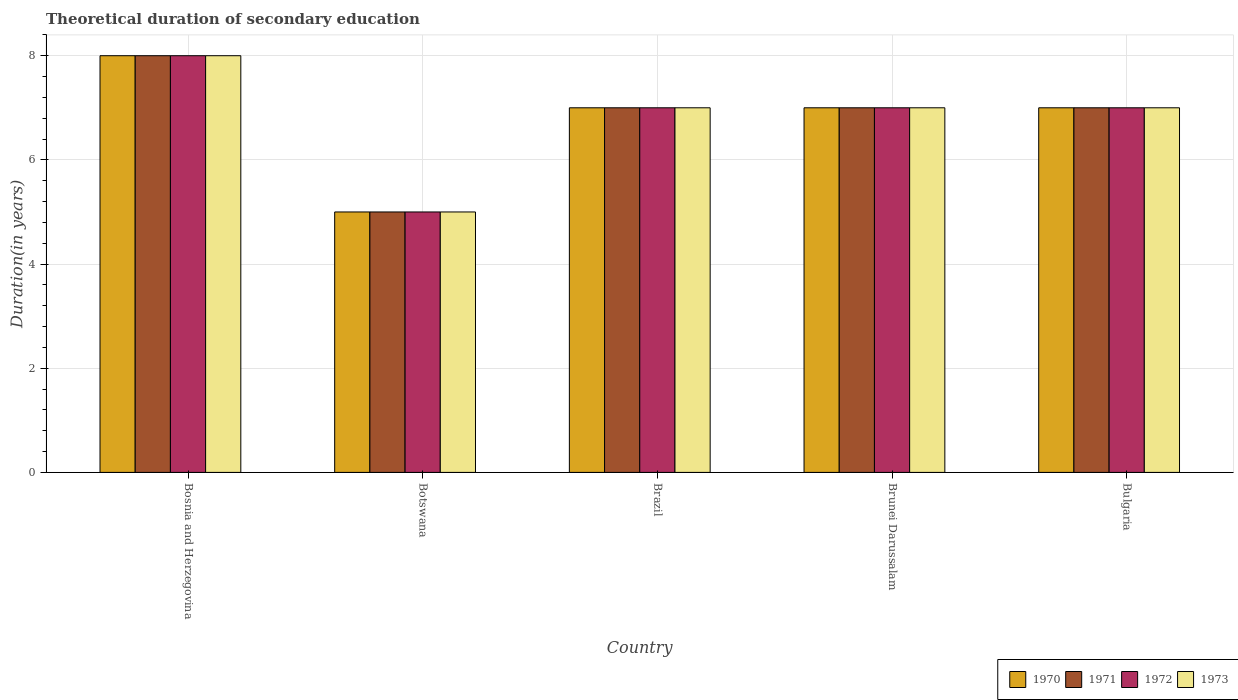How many groups of bars are there?
Provide a succinct answer. 5. Are the number of bars on each tick of the X-axis equal?
Keep it short and to the point. Yes. How many bars are there on the 5th tick from the left?
Your response must be concise. 4. How many bars are there on the 2nd tick from the right?
Offer a very short reply. 4. What is the label of the 2nd group of bars from the left?
Provide a succinct answer. Botswana. In how many cases, is the number of bars for a given country not equal to the number of legend labels?
Make the answer very short. 0. What is the total theoretical duration of secondary education in 1971 in Bulgaria?
Keep it short and to the point. 7. In which country was the total theoretical duration of secondary education in 1972 maximum?
Offer a very short reply. Bosnia and Herzegovina. In which country was the total theoretical duration of secondary education in 1971 minimum?
Make the answer very short. Botswana. What is the total total theoretical duration of secondary education in 1973 in the graph?
Your response must be concise. 34. What is the difference between the total theoretical duration of secondary education in 1972 in Brazil and that in Brunei Darussalam?
Provide a succinct answer. 0. What is the average total theoretical duration of secondary education in 1970 per country?
Your response must be concise. 6.8. In how many countries, is the total theoretical duration of secondary education in 1972 greater than 3.6 years?
Offer a terse response. 5. What is the ratio of the total theoretical duration of secondary education in 1971 in Bosnia and Herzegovina to that in Brunei Darussalam?
Offer a very short reply. 1.14. What is the difference between the highest and the lowest total theoretical duration of secondary education in 1972?
Ensure brevity in your answer.  3. In how many countries, is the total theoretical duration of secondary education in 1970 greater than the average total theoretical duration of secondary education in 1970 taken over all countries?
Your response must be concise. 4. Is it the case that in every country, the sum of the total theoretical duration of secondary education in 1971 and total theoretical duration of secondary education in 1972 is greater than the sum of total theoretical duration of secondary education in 1970 and total theoretical duration of secondary education in 1973?
Give a very brief answer. No. Is it the case that in every country, the sum of the total theoretical duration of secondary education in 1970 and total theoretical duration of secondary education in 1972 is greater than the total theoretical duration of secondary education in 1971?
Make the answer very short. Yes. How many bars are there?
Give a very brief answer. 20. Are all the bars in the graph horizontal?
Provide a succinct answer. No. What is the difference between two consecutive major ticks on the Y-axis?
Ensure brevity in your answer.  2. Are the values on the major ticks of Y-axis written in scientific E-notation?
Provide a short and direct response. No. Does the graph contain any zero values?
Your answer should be very brief. No. What is the title of the graph?
Your answer should be very brief. Theoretical duration of secondary education. Does "2015" appear as one of the legend labels in the graph?
Offer a very short reply. No. What is the label or title of the Y-axis?
Your answer should be compact. Duration(in years). What is the Duration(in years) of 1972 in Bosnia and Herzegovina?
Offer a very short reply. 8. What is the Duration(in years) of 1973 in Bosnia and Herzegovina?
Offer a terse response. 8. What is the Duration(in years) of 1971 in Botswana?
Your answer should be compact. 5. What is the Duration(in years) of 1973 in Botswana?
Make the answer very short. 5. What is the Duration(in years) of 1970 in Brazil?
Keep it short and to the point. 7. What is the Duration(in years) in 1970 in Bulgaria?
Make the answer very short. 7. What is the Duration(in years) in 1971 in Bulgaria?
Keep it short and to the point. 7. Across all countries, what is the maximum Duration(in years) of 1970?
Provide a succinct answer. 8. Across all countries, what is the maximum Duration(in years) of 1971?
Ensure brevity in your answer.  8. Across all countries, what is the maximum Duration(in years) of 1972?
Your answer should be very brief. 8. Across all countries, what is the maximum Duration(in years) of 1973?
Your answer should be very brief. 8. Across all countries, what is the minimum Duration(in years) in 1970?
Make the answer very short. 5. Across all countries, what is the minimum Duration(in years) in 1973?
Give a very brief answer. 5. What is the total Duration(in years) in 1970 in the graph?
Your answer should be compact. 34. What is the total Duration(in years) in 1973 in the graph?
Provide a short and direct response. 34. What is the difference between the Duration(in years) of 1970 in Bosnia and Herzegovina and that in Botswana?
Keep it short and to the point. 3. What is the difference between the Duration(in years) in 1971 in Bosnia and Herzegovina and that in Botswana?
Your answer should be very brief. 3. What is the difference between the Duration(in years) in 1972 in Bosnia and Herzegovina and that in Botswana?
Provide a succinct answer. 3. What is the difference between the Duration(in years) of 1973 in Bosnia and Herzegovina and that in Botswana?
Your answer should be compact. 3. What is the difference between the Duration(in years) of 1971 in Bosnia and Herzegovina and that in Brazil?
Ensure brevity in your answer.  1. What is the difference between the Duration(in years) in 1972 in Bosnia and Herzegovina and that in Brazil?
Make the answer very short. 1. What is the difference between the Duration(in years) of 1970 in Bosnia and Herzegovina and that in Brunei Darussalam?
Your response must be concise. 1. What is the difference between the Duration(in years) of 1970 in Bosnia and Herzegovina and that in Bulgaria?
Offer a terse response. 1. What is the difference between the Duration(in years) in 1973 in Bosnia and Herzegovina and that in Bulgaria?
Your response must be concise. 1. What is the difference between the Duration(in years) of 1971 in Botswana and that in Brazil?
Give a very brief answer. -2. What is the difference between the Duration(in years) of 1973 in Botswana and that in Brazil?
Provide a short and direct response. -2. What is the difference between the Duration(in years) in 1971 in Botswana and that in Brunei Darussalam?
Offer a terse response. -2. What is the difference between the Duration(in years) in 1972 in Botswana and that in Brunei Darussalam?
Provide a short and direct response. -2. What is the difference between the Duration(in years) of 1973 in Botswana and that in Brunei Darussalam?
Offer a very short reply. -2. What is the difference between the Duration(in years) in 1970 in Botswana and that in Bulgaria?
Offer a terse response. -2. What is the difference between the Duration(in years) of 1971 in Brazil and that in Brunei Darussalam?
Offer a very short reply. 0. What is the difference between the Duration(in years) of 1972 in Brazil and that in Brunei Darussalam?
Your answer should be very brief. 0. What is the difference between the Duration(in years) in 1970 in Brazil and that in Bulgaria?
Your answer should be compact. 0. What is the difference between the Duration(in years) in 1971 in Brazil and that in Bulgaria?
Your answer should be very brief. 0. What is the difference between the Duration(in years) of 1973 in Brazil and that in Bulgaria?
Your answer should be very brief. 0. What is the difference between the Duration(in years) of 1973 in Brunei Darussalam and that in Bulgaria?
Make the answer very short. 0. What is the difference between the Duration(in years) in 1970 in Bosnia and Herzegovina and the Duration(in years) in 1972 in Botswana?
Offer a terse response. 3. What is the difference between the Duration(in years) of 1971 in Bosnia and Herzegovina and the Duration(in years) of 1972 in Botswana?
Provide a succinct answer. 3. What is the difference between the Duration(in years) in 1970 in Bosnia and Herzegovina and the Duration(in years) in 1972 in Brazil?
Offer a very short reply. 1. What is the difference between the Duration(in years) of 1970 in Bosnia and Herzegovina and the Duration(in years) of 1973 in Brazil?
Offer a terse response. 1. What is the difference between the Duration(in years) of 1971 in Bosnia and Herzegovina and the Duration(in years) of 1972 in Brazil?
Provide a short and direct response. 1. What is the difference between the Duration(in years) in 1972 in Bosnia and Herzegovina and the Duration(in years) in 1973 in Brazil?
Give a very brief answer. 1. What is the difference between the Duration(in years) of 1970 in Bosnia and Herzegovina and the Duration(in years) of 1973 in Brunei Darussalam?
Provide a short and direct response. 1. What is the difference between the Duration(in years) of 1971 in Bosnia and Herzegovina and the Duration(in years) of 1972 in Brunei Darussalam?
Your response must be concise. 1. What is the difference between the Duration(in years) of 1972 in Bosnia and Herzegovina and the Duration(in years) of 1973 in Brunei Darussalam?
Your answer should be very brief. 1. What is the difference between the Duration(in years) in 1970 in Bosnia and Herzegovina and the Duration(in years) in 1973 in Bulgaria?
Your answer should be very brief. 1. What is the difference between the Duration(in years) in 1972 in Bosnia and Herzegovina and the Duration(in years) in 1973 in Bulgaria?
Keep it short and to the point. 1. What is the difference between the Duration(in years) of 1970 in Botswana and the Duration(in years) of 1971 in Brazil?
Offer a very short reply. -2. What is the difference between the Duration(in years) in 1970 in Botswana and the Duration(in years) in 1972 in Brazil?
Offer a very short reply. -2. What is the difference between the Duration(in years) of 1970 in Botswana and the Duration(in years) of 1973 in Brazil?
Keep it short and to the point. -2. What is the difference between the Duration(in years) in 1971 in Botswana and the Duration(in years) in 1972 in Brazil?
Ensure brevity in your answer.  -2. What is the difference between the Duration(in years) in 1971 in Botswana and the Duration(in years) in 1973 in Brazil?
Offer a terse response. -2. What is the difference between the Duration(in years) of 1970 in Botswana and the Duration(in years) of 1971 in Brunei Darussalam?
Provide a short and direct response. -2. What is the difference between the Duration(in years) in 1970 in Botswana and the Duration(in years) in 1972 in Brunei Darussalam?
Provide a succinct answer. -2. What is the difference between the Duration(in years) of 1970 in Botswana and the Duration(in years) of 1973 in Brunei Darussalam?
Keep it short and to the point. -2. What is the difference between the Duration(in years) in 1971 in Botswana and the Duration(in years) in 1973 in Brunei Darussalam?
Offer a very short reply. -2. What is the difference between the Duration(in years) in 1972 in Botswana and the Duration(in years) in 1973 in Brunei Darussalam?
Offer a very short reply. -2. What is the difference between the Duration(in years) of 1970 in Botswana and the Duration(in years) of 1972 in Bulgaria?
Your response must be concise. -2. What is the difference between the Duration(in years) of 1970 in Botswana and the Duration(in years) of 1973 in Bulgaria?
Offer a very short reply. -2. What is the difference between the Duration(in years) of 1971 in Botswana and the Duration(in years) of 1973 in Bulgaria?
Your answer should be very brief. -2. What is the difference between the Duration(in years) of 1970 in Brazil and the Duration(in years) of 1971 in Brunei Darussalam?
Keep it short and to the point. 0. What is the difference between the Duration(in years) in 1970 in Brazil and the Duration(in years) in 1973 in Brunei Darussalam?
Your answer should be very brief. 0. What is the difference between the Duration(in years) of 1972 in Brazil and the Duration(in years) of 1973 in Brunei Darussalam?
Your answer should be very brief. 0. What is the difference between the Duration(in years) in 1970 in Brazil and the Duration(in years) in 1972 in Bulgaria?
Keep it short and to the point. 0. What is the difference between the Duration(in years) of 1971 in Brazil and the Duration(in years) of 1972 in Bulgaria?
Keep it short and to the point. 0. What is the difference between the Duration(in years) of 1970 in Brunei Darussalam and the Duration(in years) of 1972 in Bulgaria?
Provide a short and direct response. 0. What is the difference between the Duration(in years) in 1971 in Brunei Darussalam and the Duration(in years) in 1972 in Bulgaria?
Provide a short and direct response. 0. What is the difference between the Duration(in years) of 1972 in Brunei Darussalam and the Duration(in years) of 1973 in Bulgaria?
Offer a very short reply. 0. What is the average Duration(in years) of 1970 per country?
Give a very brief answer. 6.8. What is the average Duration(in years) in 1972 per country?
Offer a very short reply. 6.8. What is the average Duration(in years) of 1973 per country?
Keep it short and to the point. 6.8. What is the difference between the Duration(in years) in 1970 and Duration(in years) in 1973 in Bosnia and Herzegovina?
Your response must be concise. 0. What is the difference between the Duration(in years) of 1971 and Duration(in years) of 1973 in Bosnia and Herzegovina?
Provide a succinct answer. 0. What is the difference between the Duration(in years) of 1970 and Duration(in years) of 1971 in Botswana?
Your response must be concise. 0. What is the difference between the Duration(in years) of 1971 and Duration(in years) of 1972 in Botswana?
Offer a very short reply. 0. What is the difference between the Duration(in years) in 1971 and Duration(in years) in 1973 in Botswana?
Offer a very short reply. 0. What is the difference between the Duration(in years) in 1970 and Duration(in years) in 1971 in Brazil?
Your answer should be compact. 0. What is the difference between the Duration(in years) of 1970 and Duration(in years) of 1972 in Brazil?
Provide a short and direct response. 0. What is the difference between the Duration(in years) in 1970 and Duration(in years) in 1973 in Brazil?
Provide a short and direct response. 0. What is the difference between the Duration(in years) of 1971 and Duration(in years) of 1973 in Brazil?
Offer a very short reply. 0. What is the difference between the Duration(in years) of 1970 and Duration(in years) of 1973 in Brunei Darussalam?
Make the answer very short. 0. What is the difference between the Duration(in years) of 1971 and Duration(in years) of 1972 in Brunei Darussalam?
Offer a terse response. 0. What is the difference between the Duration(in years) of 1970 and Duration(in years) of 1973 in Bulgaria?
Offer a terse response. 0. What is the ratio of the Duration(in years) of 1970 in Bosnia and Herzegovina to that in Botswana?
Your answer should be very brief. 1.6. What is the ratio of the Duration(in years) of 1970 in Bosnia and Herzegovina to that in Brazil?
Provide a short and direct response. 1.14. What is the ratio of the Duration(in years) in 1972 in Bosnia and Herzegovina to that in Brazil?
Ensure brevity in your answer.  1.14. What is the ratio of the Duration(in years) of 1973 in Bosnia and Herzegovina to that in Brazil?
Your answer should be very brief. 1.14. What is the ratio of the Duration(in years) in 1970 in Bosnia and Herzegovina to that in Brunei Darussalam?
Offer a very short reply. 1.14. What is the ratio of the Duration(in years) in 1971 in Bosnia and Herzegovina to that in Brunei Darussalam?
Make the answer very short. 1.14. What is the ratio of the Duration(in years) of 1972 in Bosnia and Herzegovina to that in Brunei Darussalam?
Your answer should be compact. 1.14. What is the ratio of the Duration(in years) of 1970 in Bosnia and Herzegovina to that in Bulgaria?
Your answer should be compact. 1.14. What is the ratio of the Duration(in years) in 1971 in Bosnia and Herzegovina to that in Bulgaria?
Make the answer very short. 1.14. What is the ratio of the Duration(in years) in 1973 in Bosnia and Herzegovina to that in Bulgaria?
Give a very brief answer. 1.14. What is the ratio of the Duration(in years) in 1970 in Botswana to that in Brazil?
Offer a terse response. 0.71. What is the ratio of the Duration(in years) in 1972 in Botswana to that in Brazil?
Provide a succinct answer. 0.71. What is the ratio of the Duration(in years) of 1970 in Botswana to that in Brunei Darussalam?
Your answer should be very brief. 0.71. What is the ratio of the Duration(in years) of 1972 in Botswana to that in Brunei Darussalam?
Offer a terse response. 0.71. What is the ratio of the Duration(in years) of 1970 in Botswana to that in Bulgaria?
Provide a short and direct response. 0.71. What is the ratio of the Duration(in years) of 1971 in Botswana to that in Bulgaria?
Keep it short and to the point. 0.71. What is the ratio of the Duration(in years) of 1973 in Botswana to that in Bulgaria?
Make the answer very short. 0.71. What is the ratio of the Duration(in years) of 1970 in Brazil to that in Brunei Darussalam?
Offer a very short reply. 1. What is the ratio of the Duration(in years) of 1972 in Brazil to that in Brunei Darussalam?
Offer a terse response. 1. What is the ratio of the Duration(in years) of 1973 in Brazil to that in Brunei Darussalam?
Your answer should be very brief. 1. What is the ratio of the Duration(in years) of 1970 in Brazil to that in Bulgaria?
Provide a short and direct response. 1. What is the ratio of the Duration(in years) of 1971 in Brazil to that in Bulgaria?
Your answer should be very brief. 1. What is the ratio of the Duration(in years) of 1972 in Brazil to that in Bulgaria?
Provide a succinct answer. 1. What is the ratio of the Duration(in years) of 1973 in Brazil to that in Bulgaria?
Your answer should be very brief. 1. What is the ratio of the Duration(in years) in 1971 in Brunei Darussalam to that in Bulgaria?
Your response must be concise. 1. What is the difference between the highest and the second highest Duration(in years) of 1970?
Your answer should be compact. 1. What is the difference between the highest and the second highest Duration(in years) in 1971?
Provide a short and direct response. 1. What is the difference between the highest and the second highest Duration(in years) of 1972?
Provide a short and direct response. 1. What is the difference between the highest and the lowest Duration(in years) of 1970?
Make the answer very short. 3. What is the difference between the highest and the lowest Duration(in years) of 1973?
Your answer should be very brief. 3. 